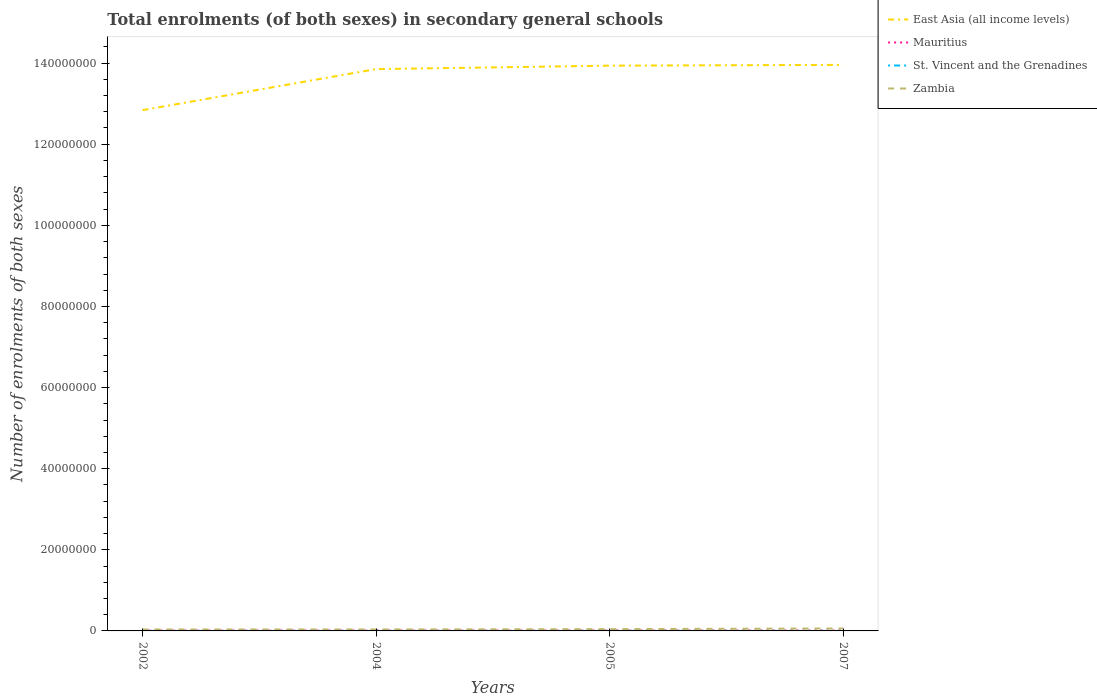How many different coloured lines are there?
Your answer should be very brief. 4. Does the line corresponding to East Asia (all income levels) intersect with the line corresponding to Mauritius?
Offer a terse response. No. Across all years, what is the maximum number of enrolments in secondary schools in St. Vincent and the Grenadines?
Your answer should be compact. 8157. What is the total number of enrolments in secondary schools in Zambia in the graph?
Provide a succinct answer. -2.44e+05. What is the difference between the highest and the second highest number of enrolments in secondary schools in Zambia?
Make the answer very short. 2.56e+05. Is the number of enrolments in secondary schools in East Asia (all income levels) strictly greater than the number of enrolments in secondary schools in St. Vincent and the Grenadines over the years?
Your response must be concise. No. How many lines are there?
Your answer should be compact. 4. How many years are there in the graph?
Your answer should be very brief. 4. What is the difference between two consecutive major ticks on the Y-axis?
Ensure brevity in your answer.  2.00e+07. Are the values on the major ticks of Y-axis written in scientific E-notation?
Provide a succinct answer. No. Where does the legend appear in the graph?
Make the answer very short. Top right. What is the title of the graph?
Offer a very short reply. Total enrolments (of both sexes) in secondary general schools. Does "Sierra Leone" appear as one of the legend labels in the graph?
Keep it short and to the point. No. What is the label or title of the Y-axis?
Provide a short and direct response. Number of enrolments of both sexes. What is the Number of enrolments of both sexes of East Asia (all income levels) in 2002?
Make the answer very short. 1.28e+08. What is the Number of enrolments of both sexes of Mauritius in 2002?
Offer a terse response. 9.97e+04. What is the Number of enrolments of both sexes in St. Vincent and the Grenadines in 2002?
Give a very brief answer. 8157. What is the Number of enrolments of both sexes in Zambia in 2002?
Ensure brevity in your answer.  3.51e+05. What is the Number of enrolments of both sexes in East Asia (all income levels) in 2004?
Give a very brief answer. 1.39e+08. What is the Number of enrolments of both sexes of Mauritius in 2004?
Make the answer very short. 1.06e+05. What is the Number of enrolments of both sexes of St. Vincent and the Grenadines in 2004?
Provide a succinct answer. 8629. What is the Number of enrolments of both sexes in Zambia in 2004?
Give a very brief answer. 3.64e+05. What is the Number of enrolments of both sexes of East Asia (all income levels) in 2005?
Make the answer very short. 1.39e+08. What is the Number of enrolments of both sexes of Mauritius in 2005?
Offer a very short reply. 1.10e+05. What is the Number of enrolments of both sexes of St. Vincent and the Grenadines in 2005?
Give a very brief answer. 9393. What is the Number of enrolments of both sexes of Zambia in 2005?
Give a very brief answer. 4.43e+05. What is the Number of enrolments of both sexes in East Asia (all income levels) in 2007?
Provide a short and direct response. 1.40e+08. What is the Number of enrolments of both sexes in Mauritius in 2007?
Make the answer very short. 1.17e+05. What is the Number of enrolments of both sexes in St. Vincent and the Grenadines in 2007?
Offer a terse response. 1.12e+04. What is the Number of enrolments of both sexes of Zambia in 2007?
Offer a terse response. 6.07e+05. Across all years, what is the maximum Number of enrolments of both sexes in East Asia (all income levels)?
Offer a very short reply. 1.40e+08. Across all years, what is the maximum Number of enrolments of both sexes of Mauritius?
Provide a succinct answer. 1.17e+05. Across all years, what is the maximum Number of enrolments of both sexes in St. Vincent and the Grenadines?
Provide a short and direct response. 1.12e+04. Across all years, what is the maximum Number of enrolments of both sexes of Zambia?
Provide a short and direct response. 6.07e+05. Across all years, what is the minimum Number of enrolments of both sexes of East Asia (all income levels)?
Your answer should be compact. 1.28e+08. Across all years, what is the minimum Number of enrolments of both sexes of Mauritius?
Offer a terse response. 9.97e+04. Across all years, what is the minimum Number of enrolments of both sexes in St. Vincent and the Grenadines?
Ensure brevity in your answer.  8157. Across all years, what is the minimum Number of enrolments of both sexes in Zambia?
Your answer should be very brief. 3.51e+05. What is the total Number of enrolments of both sexes in East Asia (all income levels) in the graph?
Ensure brevity in your answer.  5.46e+08. What is the total Number of enrolments of both sexes of Mauritius in the graph?
Offer a terse response. 4.33e+05. What is the total Number of enrolments of both sexes of St. Vincent and the Grenadines in the graph?
Ensure brevity in your answer.  3.74e+04. What is the total Number of enrolments of both sexes in Zambia in the graph?
Your answer should be compact. 1.77e+06. What is the difference between the Number of enrolments of both sexes in East Asia (all income levels) in 2002 and that in 2004?
Your answer should be very brief. -1.01e+07. What is the difference between the Number of enrolments of both sexes of Mauritius in 2002 and that in 2004?
Your response must be concise. -6301. What is the difference between the Number of enrolments of both sexes in St. Vincent and the Grenadines in 2002 and that in 2004?
Make the answer very short. -472. What is the difference between the Number of enrolments of both sexes of Zambia in 2002 and that in 2004?
Your response must be concise. -1.22e+04. What is the difference between the Number of enrolments of both sexes of East Asia (all income levels) in 2002 and that in 2005?
Offer a terse response. -1.10e+07. What is the difference between the Number of enrolments of both sexes in Mauritius in 2002 and that in 2005?
Provide a short and direct response. -1.06e+04. What is the difference between the Number of enrolments of both sexes in St. Vincent and the Grenadines in 2002 and that in 2005?
Your answer should be compact. -1236. What is the difference between the Number of enrolments of both sexes of Zambia in 2002 and that in 2005?
Provide a succinct answer. -9.15e+04. What is the difference between the Number of enrolments of both sexes in East Asia (all income levels) in 2002 and that in 2007?
Make the answer very short. -1.12e+07. What is the difference between the Number of enrolments of both sexes in Mauritius in 2002 and that in 2007?
Your answer should be compact. -1.70e+04. What is the difference between the Number of enrolments of both sexes in St. Vincent and the Grenadines in 2002 and that in 2007?
Provide a short and direct response. -3081. What is the difference between the Number of enrolments of both sexes of Zambia in 2002 and that in 2007?
Your answer should be compact. -2.56e+05. What is the difference between the Number of enrolments of both sexes of East Asia (all income levels) in 2004 and that in 2005?
Make the answer very short. -8.46e+05. What is the difference between the Number of enrolments of both sexes in Mauritius in 2004 and that in 2005?
Your answer should be very brief. -4299. What is the difference between the Number of enrolments of both sexes in St. Vincent and the Grenadines in 2004 and that in 2005?
Make the answer very short. -764. What is the difference between the Number of enrolments of both sexes of Zambia in 2004 and that in 2005?
Your answer should be very brief. -7.94e+04. What is the difference between the Number of enrolments of both sexes of East Asia (all income levels) in 2004 and that in 2007?
Provide a succinct answer. -1.04e+06. What is the difference between the Number of enrolments of both sexes of Mauritius in 2004 and that in 2007?
Give a very brief answer. -1.07e+04. What is the difference between the Number of enrolments of both sexes in St. Vincent and the Grenadines in 2004 and that in 2007?
Offer a very short reply. -2609. What is the difference between the Number of enrolments of both sexes in Zambia in 2004 and that in 2007?
Keep it short and to the point. -2.44e+05. What is the difference between the Number of enrolments of both sexes in East Asia (all income levels) in 2005 and that in 2007?
Keep it short and to the point. -1.95e+05. What is the difference between the Number of enrolments of both sexes in Mauritius in 2005 and that in 2007?
Offer a terse response. -6419. What is the difference between the Number of enrolments of both sexes in St. Vincent and the Grenadines in 2005 and that in 2007?
Provide a succinct answer. -1845. What is the difference between the Number of enrolments of both sexes of Zambia in 2005 and that in 2007?
Keep it short and to the point. -1.64e+05. What is the difference between the Number of enrolments of both sexes of East Asia (all income levels) in 2002 and the Number of enrolments of both sexes of Mauritius in 2004?
Offer a very short reply. 1.28e+08. What is the difference between the Number of enrolments of both sexes in East Asia (all income levels) in 2002 and the Number of enrolments of both sexes in St. Vincent and the Grenadines in 2004?
Provide a succinct answer. 1.28e+08. What is the difference between the Number of enrolments of both sexes in East Asia (all income levels) in 2002 and the Number of enrolments of both sexes in Zambia in 2004?
Your answer should be very brief. 1.28e+08. What is the difference between the Number of enrolments of both sexes of Mauritius in 2002 and the Number of enrolments of both sexes of St. Vincent and the Grenadines in 2004?
Your response must be concise. 9.11e+04. What is the difference between the Number of enrolments of both sexes in Mauritius in 2002 and the Number of enrolments of both sexes in Zambia in 2004?
Make the answer very short. -2.64e+05. What is the difference between the Number of enrolments of both sexes of St. Vincent and the Grenadines in 2002 and the Number of enrolments of both sexes of Zambia in 2004?
Offer a terse response. -3.55e+05. What is the difference between the Number of enrolments of both sexes in East Asia (all income levels) in 2002 and the Number of enrolments of both sexes in Mauritius in 2005?
Provide a short and direct response. 1.28e+08. What is the difference between the Number of enrolments of both sexes of East Asia (all income levels) in 2002 and the Number of enrolments of both sexes of St. Vincent and the Grenadines in 2005?
Make the answer very short. 1.28e+08. What is the difference between the Number of enrolments of both sexes in East Asia (all income levels) in 2002 and the Number of enrolments of both sexes in Zambia in 2005?
Ensure brevity in your answer.  1.28e+08. What is the difference between the Number of enrolments of both sexes of Mauritius in 2002 and the Number of enrolments of both sexes of St. Vincent and the Grenadines in 2005?
Make the answer very short. 9.03e+04. What is the difference between the Number of enrolments of both sexes of Mauritius in 2002 and the Number of enrolments of both sexes of Zambia in 2005?
Ensure brevity in your answer.  -3.43e+05. What is the difference between the Number of enrolments of both sexes of St. Vincent and the Grenadines in 2002 and the Number of enrolments of both sexes of Zambia in 2005?
Provide a succinct answer. -4.35e+05. What is the difference between the Number of enrolments of both sexes in East Asia (all income levels) in 2002 and the Number of enrolments of both sexes in Mauritius in 2007?
Offer a terse response. 1.28e+08. What is the difference between the Number of enrolments of both sexes of East Asia (all income levels) in 2002 and the Number of enrolments of both sexes of St. Vincent and the Grenadines in 2007?
Make the answer very short. 1.28e+08. What is the difference between the Number of enrolments of both sexes in East Asia (all income levels) in 2002 and the Number of enrolments of both sexes in Zambia in 2007?
Offer a very short reply. 1.28e+08. What is the difference between the Number of enrolments of both sexes in Mauritius in 2002 and the Number of enrolments of both sexes in St. Vincent and the Grenadines in 2007?
Offer a very short reply. 8.84e+04. What is the difference between the Number of enrolments of both sexes of Mauritius in 2002 and the Number of enrolments of both sexes of Zambia in 2007?
Offer a very short reply. -5.08e+05. What is the difference between the Number of enrolments of both sexes in St. Vincent and the Grenadines in 2002 and the Number of enrolments of both sexes in Zambia in 2007?
Your answer should be very brief. -5.99e+05. What is the difference between the Number of enrolments of both sexes of East Asia (all income levels) in 2004 and the Number of enrolments of both sexes of Mauritius in 2005?
Ensure brevity in your answer.  1.38e+08. What is the difference between the Number of enrolments of both sexes in East Asia (all income levels) in 2004 and the Number of enrolments of both sexes in St. Vincent and the Grenadines in 2005?
Make the answer very short. 1.39e+08. What is the difference between the Number of enrolments of both sexes in East Asia (all income levels) in 2004 and the Number of enrolments of both sexes in Zambia in 2005?
Keep it short and to the point. 1.38e+08. What is the difference between the Number of enrolments of both sexes in Mauritius in 2004 and the Number of enrolments of both sexes in St. Vincent and the Grenadines in 2005?
Offer a very short reply. 9.66e+04. What is the difference between the Number of enrolments of both sexes of Mauritius in 2004 and the Number of enrolments of both sexes of Zambia in 2005?
Provide a short and direct response. -3.37e+05. What is the difference between the Number of enrolments of both sexes of St. Vincent and the Grenadines in 2004 and the Number of enrolments of both sexes of Zambia in 2005?
Offer a very short reply. -4.34e+05. What is the difference between the Number of enrolments of both sexes in East Asia (all income levels) in 2004 and the Number of enrolments of both sexes in Mauritius in 2007?
Offer a very short reply. 1.38e+08. What is the difference between the Number of enrolments of both sexes in East Asia (all income levels) in 2004 and the Number of enrolments of both sexes in St. Vincent and the Grenadines in 2007?
Make the answer very short. 1.39e+08. What is the difference between the Number of enrolments of both sexes of East Asia (all income levels) in 2004 and the Number of enrolments of both sexes of Zambia in 2007?
Offer a terse response. 1.38e+08. What is the difference between the Number of enrolments of both sexes in Mauritius in 2004 and the Number of enrolments of both sexes in St. Vincent and the Grenadines in 2007?
Give a very brief answer. 9.48e+04. What is the difference between the Number of enrolments of both sexes in Mauritius in 2004 and the Number of enrolments of both sexes in Zambia in 2007?
Keep it short and to the point. -5.01e+05. What is the difference between the Number of enrolments of both sexes in St. Vincent and the Grenadines in 2004 and the Number of enrolments of both sexes in Zambia in 2007?
Provide a succinct answer. -5.99e+05. What is the difference between the Number of enrolments of both sexes of East Asia (all income levels) in 2005 and the Number of enrolments of both sexes of Mauritius in 2007?
Your answer should be compact. 1.39e+08. What is the difference between the Number of enrolments of both sexes in East Asia (all income levels) in 2005 and the Number of enrolments of both sexes in St. Vincent and the Grenadines in 2007?
Your answer should be compact. 1.39e+08. What is the difference between the Number of enrolments of both sexes of East Asia (all income levels) in 2005 and the Number of enrolments of both sexes of Zambia in 2007?
Ensure brevity in your answer.  1.39e+08. What is the difference between the Number of enrolments of both sexes of Mauritius in 2005 and the Number of enrolments of both sexes of St. Vincent and the Grenadines in 2007?
Ensure brevity in your answer.  9.90e+04. What is the difference between the Number of enrolments of both sexes in Mauritius in 2005 and the Number of enrolments of both sexes in Zambia in 2007?
Your answer should be compact. -4.97e+05. What is the difference between the Number of enrolments of both sexes of St. Vincent and the Grenadines in 2005 and the Number of enrolments of both sexes of Zambia in 2007?
Provide a succinct answer. -5.98e+05. What is the average Number of enrolments of both sexes of East Asia (all income levels) per year?
Offer a very short reply. 1.36e+08. What is the average Number of enrolments of both sexes in Mauritius per year?
Offer a terse response. 1.08e+05. What is the average Number of enrolments of both sexes in St. Vincent and the Grenadines per year?
Ensure brevity in your answer.  9354.25. What is the average Number of enrolments of both sexes in Zambia per year?
Offer a terse response. 4.41e+05. In the year 2002, what is the difference between the Number of enrolments of both sexes of East Asia (all income levels) and Number of enrolments of both sexes of Mauritius?
Your response must be concise. 1.28e+08. In the year 2002, what is the difference between the Number of enrolments of both sexes of East Asia (all income levels) and Number of enrolments of both sexes of St. Vincent and the Grenadines?
Provide a succinct answer. 1.28e+08. In the year 2002, what is the difference between the Number of enrolments of both sexes of East Asia (all income levels) and Number of enrolments of both sexes of Zambia?
Your response must be concise. 1.28e+08. In the year 2002, what is the difference between the Number of enrolments of both sexes of Mauritius and Number of enrolments of both sexes of St. Vincent and the Grenadines?
Your answer should be very brief. 9.15e+04. In the year 2002, what is the difference between the Number of enrolments of both sexes of Mauritius and Number of enrolments of both sexes of Zambia?
Provide a succinct answer. -2.52e+05. In the year 2002, what is the difference between the Number of enrolments of both sexes in St. Vincent and the Grenadines and Number of enrolments of both sexes in Zambia?
Ensure brevity in your answer.  -3.43e+05. In the year 2004, what is the difference between the Number of enrolments of both sexes in East Asia (all income levels) and Number of enrolments of both sexes in Mauritius?
Your answer should be compact. 1.38e+08. In the year 2004, what is the difference between the Number of enrolments of both sexes of East Asia (all income levels) and Number of enrolments of both sexes of St. Vincent and the Grenadines?
Provide a short and direct response. 1.39e+08. In the year 2004, what is the difference between the Number of enrolments of both sexes in East Asia (all income levels) and Number of enrolments of both sexes in Zambia?
Offer a terse response. 1.38e+08. In the year 2004, what is the difference between the Number of enrolments of both sexes of Mauritius and Number of enrolments of both sexes of St. Vincent and the Grenadines?
Your answer should be compact. 9.74e+04. In the year 2004, what is the difference between the Number of enrolments of both sexes of Mauritius and Number of enrolments of both sexes of Zambia?
Your answer should be compact. -2.58e+05. In the year 2004, what is the difference between the Number of enrolments of both sexes in St. Vincent and the Grenadines and Number of enrolments of both sexes in Zambia?
Your answer should be compact. -3.55e+05. In the year 2005, what is the difference between the Number of enrolments of both sexes of East Asia (all income levels) and Number of enrolments of both sexes of Mauritius?
Offer a very short reply. 1.39e+08. In the year 2005, what is the difference between the Number of enrolments of both sexes of East Asia (all income levels) and Number of enrolments of both sexes of St. Vincent and the Grenadines?
Your answer should be very brief. 1.39e+08. In the year 2005, what is the difference between the Number of enrolments of both sexes in East Asia (all income levels) and Number of enrolments of both sexes in Zambia?
Ensure brevity in your answer.  1.39e+08. In the year 2005, what is the difference between the Number of enrolments of both sexes in Mauritius and Number of enrolments of both sexes in St. Vincent and the Grenadines?
Offer a very short reply. 1.01e+05. In the year 2005, what is the difference between the Number of enrolments of both sexes in Mauritius and Number of enrolments of both sexes in Zambia?
Give a very brief answer. -3.33e+05. In the year 2005, what is the difference between the Number of enrolments of both sexes of St. Vincent and the Grenadines and Number of enrolments of both sexes of Zambia?
Provide a short and direct response. -4.34e+05. In the year 2007, what is the difference between the Number of enrolments of both sexes in East Asia (all income levels) and Number of enrolments of both sexes in Mauritius?
Provide a short and direct response. 1.39e+08. In the year 2007, what is the difference between the Number of enrolments of both sexes in East Asia (all income levels) and Number of enrolments of both sexes in St. Vincent and the Grenadines?
Your answer should be very brief. 1.40e+08. In the year 2007, what is the difference between the Number of enrolments of both sexes of East Asia (all income levels) and Number of enrolments of both sexes of Zambia?
Your response must be concise. 1.39e+08. In the year 2007, what is the difference between the Number of enrolments of both sexes in Mauritius and Number of enrolments of both sexes in St. Vincent and the Grenadines?
Your answer should be very brief. 1.05e+05. In the year 2007, what is the difference between the Number of enrolments of both sexes of Mauritius and Number of enrolments of both sexes of Zambia?
Your answer should be compact. -4.91e+05. In the year 2007, what is the difference between the Number of enrolments of both sexes of St. Vincent and the Grenadines and Number of enrolments of both sexes of Zambia?
Offer a terse response. -5.96e+05. What is the ratio of the Number of enrolments of both sexes of East Asia (all income levels) in 2002 to that in 2004?
Make the answer very short. 0.93. What is the ratio of the Number of enrolments of both sexes of Mauritius in 2002 to that in 2004?
Provide a succinct answer. 0.94. What is the ratio of the Number of enrolments of both sexes of St. Vincent and the Grenadines in 2002 to that in 2004?
Provide a short and direct response. 0.95. What is the ratio of the Number of enrolments of both sexes of Zambia in 2002 to that in 2004?
Provide a succinct answer. 0.97. What is the ratio of the Number of enrolments of both sexes in East Asia (all income levels) in 2002 to that in 2005?
Offer a terse response. 0.92. What is the ratio of the Number of enrolments of both sexes in Mauritius in 2002 to that in 2005?
Ensure brevity in your answer.  0.9. What is the ratio of the Number of enrolments of both sexes of St. Vincent and the Grenadines in 2002 to that in 2005?
Keep it short and to the point. 0.87. What is the ratio of the Number of enrolments of both sexes in Zambia in 2002 to that in 2005?
Keep it short and to the point. 0.79. What is the ratio of the Number of enrolments of both sexes of Mauritius in 2002 to that in 2007?
Give a very brief answer. 0.85. What is the ratio of the Number of enrolments of both sexes of St. Vincent and the Grenadines in 2002 to that in 2007?
Your answer should be compact. 0.73. What is the ratio of the Number of enrolments of both sexes of Zambia in 2002 to that in 2007?
Offer a terse response. 0.58. What is the ratio of the Number of enrolments of both sexes in East Asia (all income levels) in 2004 to that in 2005?
Provide a short and direct response. 0.99. What is the ratio of the Number of enrolments of both sexes in Mauritius in 2004 to that in 2005?
Give a very brief answer. 0.96. What is the ratio of the Number of enrolments of both sexes in St. Vincent and the Grenadines in 2004 to that in 2005?
Provide a short and direct response. 0.92. What is the ratio of the Number of enrolments of both sexes of Zambia in 2004 to that in 2005?
Your answer should be very brief. 0.82. What is the ratio of the Number of enrolments of both sexes of East Asia (all income levels) in 2004 to that in 2007?
Offer a terse response. 0.99. What is the ratio of the Number of enrolments of both sexes of Mauritius in 2004 to that in 2007?
Give a very brief answer. 0.91. What is the ratio of the Number of enrolments of both sexes of St. Vincent and the Grenadines in 2004 to that in 2007?
Offer a very short reply. 0.77. What is the ratio of the Number of enrolments of both sexes in Zambia in 2004 to that in 2007?
Keep it short and to the point. 0.6. What is the ratio of the Number of enrolments of both sexes of Mauritius in 2005 to that in 2007?
Keep it short and to the point. 0.94. What is the ratio of the Number of enrolments of both sexes in St. Vincent and the Grenadines in 2005 to that in 2007?
Ensure brevity in your answer.  0.84. What is the ratio of the Number of enrolments of both sexes in Zambia in 2005 to that in 2007?
Your response must be concise. 0.73. What is the difference between the highest and the second highest Number of enrolments of both sexes of East Asia (all income levels)?
Your answer should be very brief. 1.95e+05. What is the difference between the highest and the second highest Number of enrolments of both sexes of Mauritius?
Your answer should be very brief. 6419. What is the difference between the highest and the second highest Number of enrolments of both sexes of St. Vincent and the Grenadines?
Your answer should be very brief. 1845. What is the difference between the highest and the second highest Number of enrolments of both sexes in Zambia?
Ensure brevity in your answer.  1.64e+05. What is the difference between the highest and the lowest Number of enrolments of both sexes in East Asia (all income levels)?
Provide a succinct answer. 1.12e+07. What is the difference between the highest and the lowest Number of enrolments of both sexes of Mauritius?
Give a very brief answer. 1.70e+04. What is the difference between the highest and the lowest Number of enrolments of both sexes in St. Vincent and the Grenadines?
Keep it short and to the point. 3081. What is the difference between the highest and the lowest Number of enrolments of both sexes of Zambia?
Your answer should be compact. 2.56e+05. 